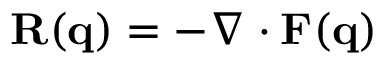<formula> <loc_0><loc_0><loc_500><loc_500>R ( q ) = - \nabla \cdot F ( q )</formula> 